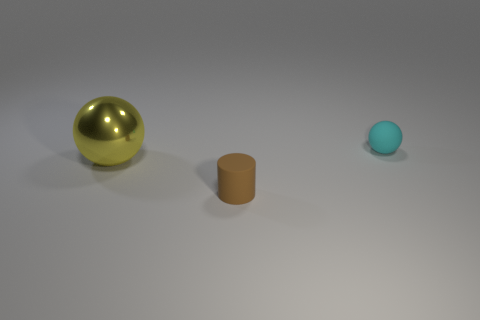There is a matte object that is in front of the matte object right of the cylinder; how big is it?
Make the answer very short. Small. How many other objects are there of the same size as the yellow ball?
Ensure brevity in your answer.  0. How big is the thing that is both behind the tiny brown cylinder and in front of the cyan sphere?
Your response must be concise. Large. What number of yellow things have the same shape as the brown matte thing?
Make the answer very short. 0. What is the material of the yellow ball?
Provide a short and direct response. Metal. Is the shape of the cyan thing the same as the large thing?
Your answer should be very brief. Yes. Is there a large object that has the same material as the big yellow sphere?
Your answer should be very brief. No. The object that is both left of the tiny cyan sphere and behind the brown cylinder is what color?
Your answer should be very brief. Yellow. What material is the thing that is to the left of the brown cylinder?
Keep it short and to the point. Metal. Are there any other matte things of the same shape as the yellow object?
Your response must be concise. Yes. 